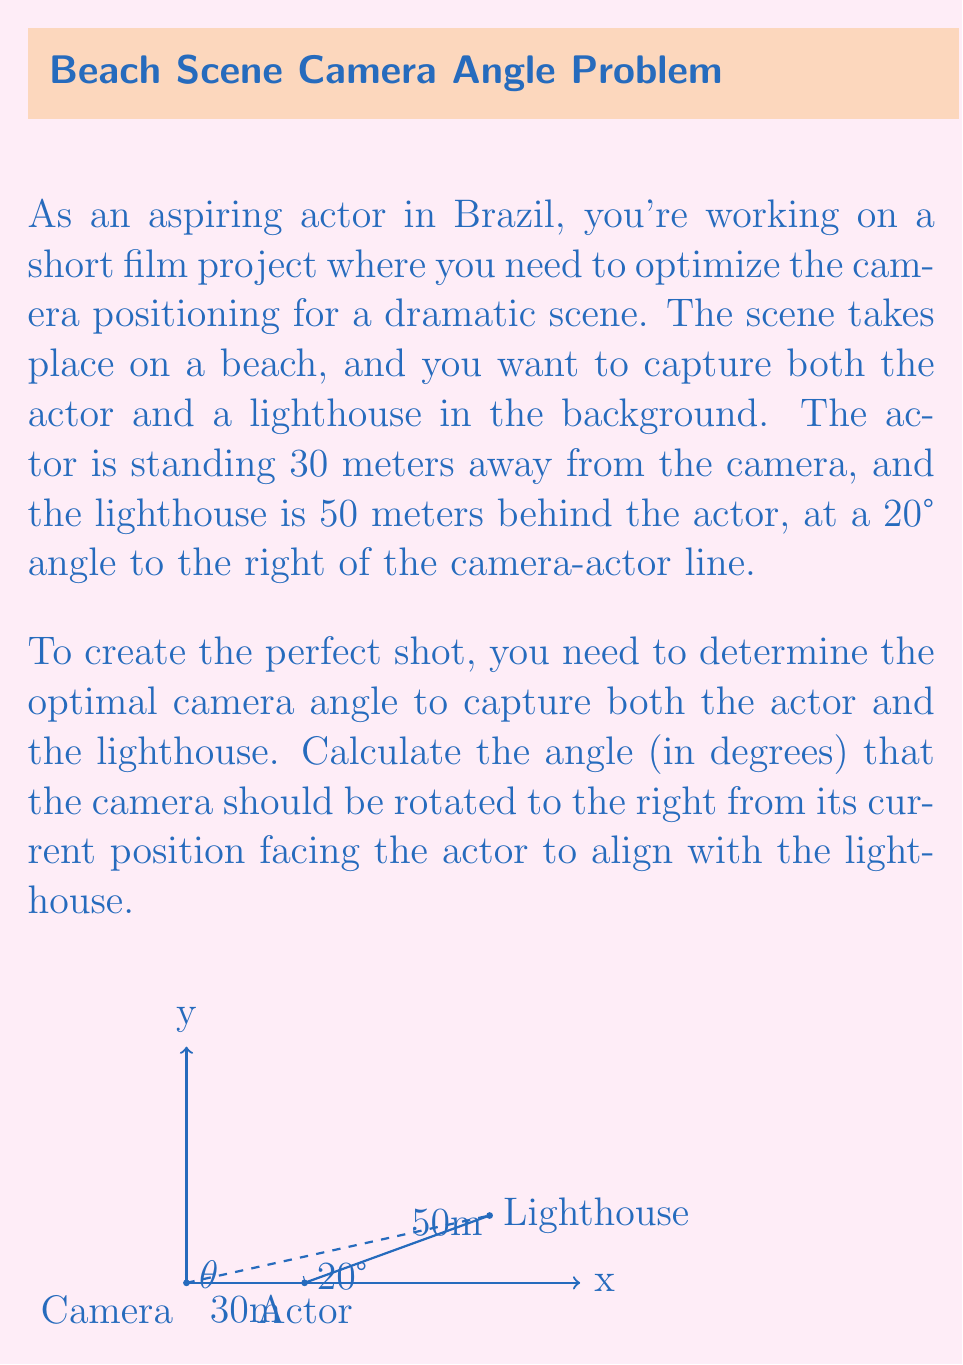Solve this math problem. Let's approach this step-by-step using trigonometry:

1) We can treat this as a triangle problem, where:
   - The camera is point A
   - The actor is point B
   - The lighthouse is point C

2) We know:
   - AB = 30 meters (distance from camera to actor)
   - BC = 50 meters (distance from actor to lighthouse)
   - Angle ABC = 20° (angle between actor-camera line and actor-lighthouse line)

3) We need to find angle CAB, which we'll call $\theta$.

4) We can use the law of sines to solve this:

   $$\frac{\sin(\theta)}{\text{BC}} = \frac{\sin(20°)}{\text{AB}}$$

5) Substituting the known values:

   $$\frac{\sin(\theta)}{50} = \frac{\sin(20°)}{30}$$

6) Cross multiply:

   $$30 \sin(\theta) = 50 \sin(20°)$$

7) Solve for $\theta$:

   $$\sin(\theta) = \frac{50 \sin(20°)}{30}$$

   $$\theta = \arcsin(\frac{50 \sin(20°)}{30})$$

8) Calculate:
   
   $$\theta = \arcsin(\frac{50 \cdot 0.3420}{30}) \approx 34.84°$$

9) Round to two decimal places:

   $$\theta \approx 34.84°$$

Thus, the camera should be rotated approximately 34.84° to the right from its current position.
Answer: $34.84°$ 